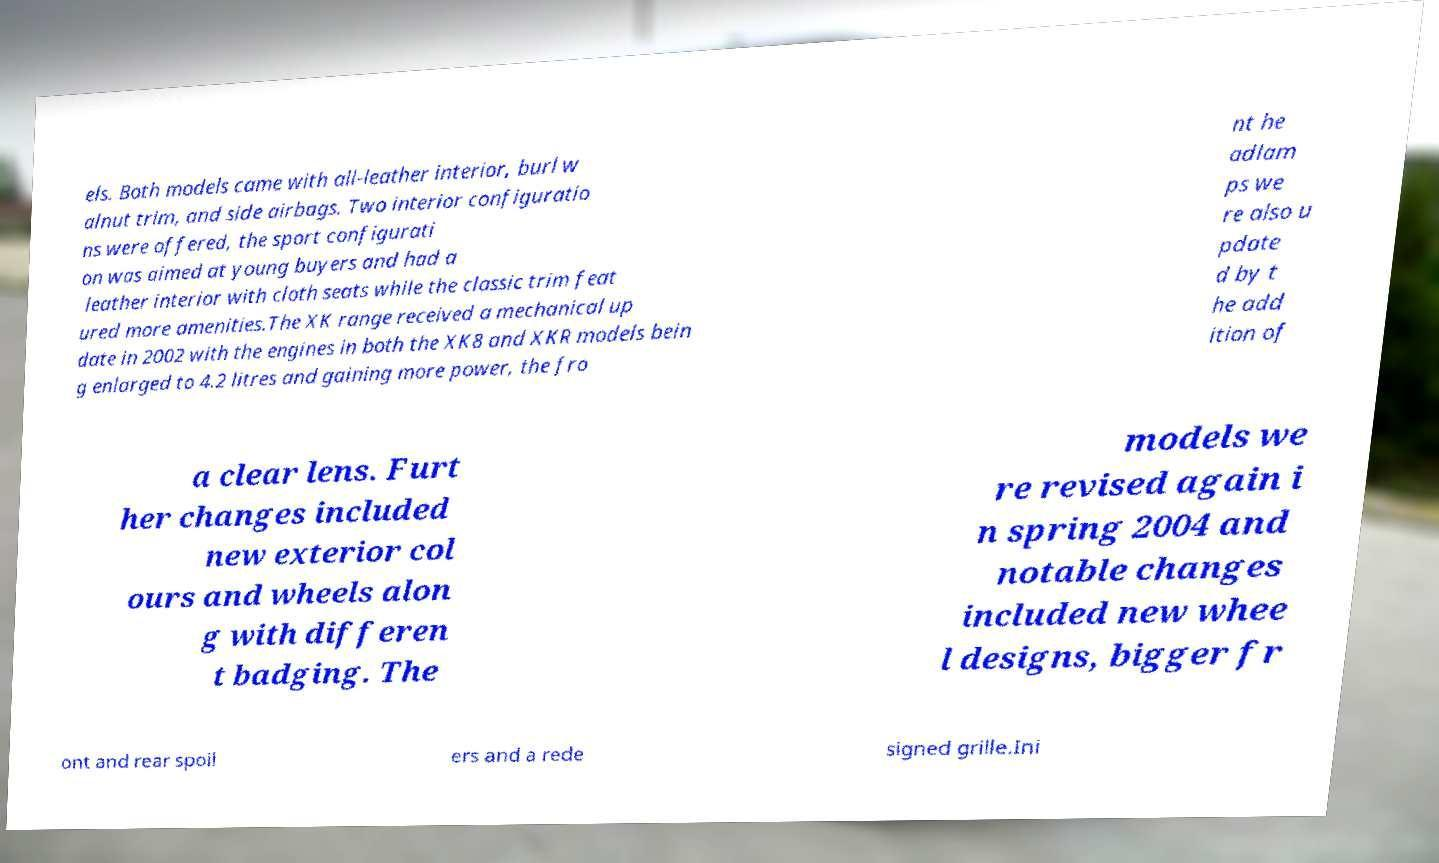Could you assist in decoding the text presented in this image and type it out clearly? els. Both models came with all-leather interior, burl w alnut trim, and side airbags. Two interior configuratio ns were offered, the sport configurati on was aimed at young buyers and had a leather interior with cloth seats while the classic trim feat ured more amenities.The XK range received a mechanical up date in 2002 with the engines in both the XK8 and XKR models bein g enlarged to 4.2 litres and gaining more power, the fro nt he adlam ps we re also u pdate d by t he add ition of a clear lens. Furt her changes included new exterior col ours and wheels alon g with differen t badging. The models we re revised again i n spring 2004 and notable changes included new whee l designs, bigger fr ont and rear spoil ers and a rede signed grille.Ini 